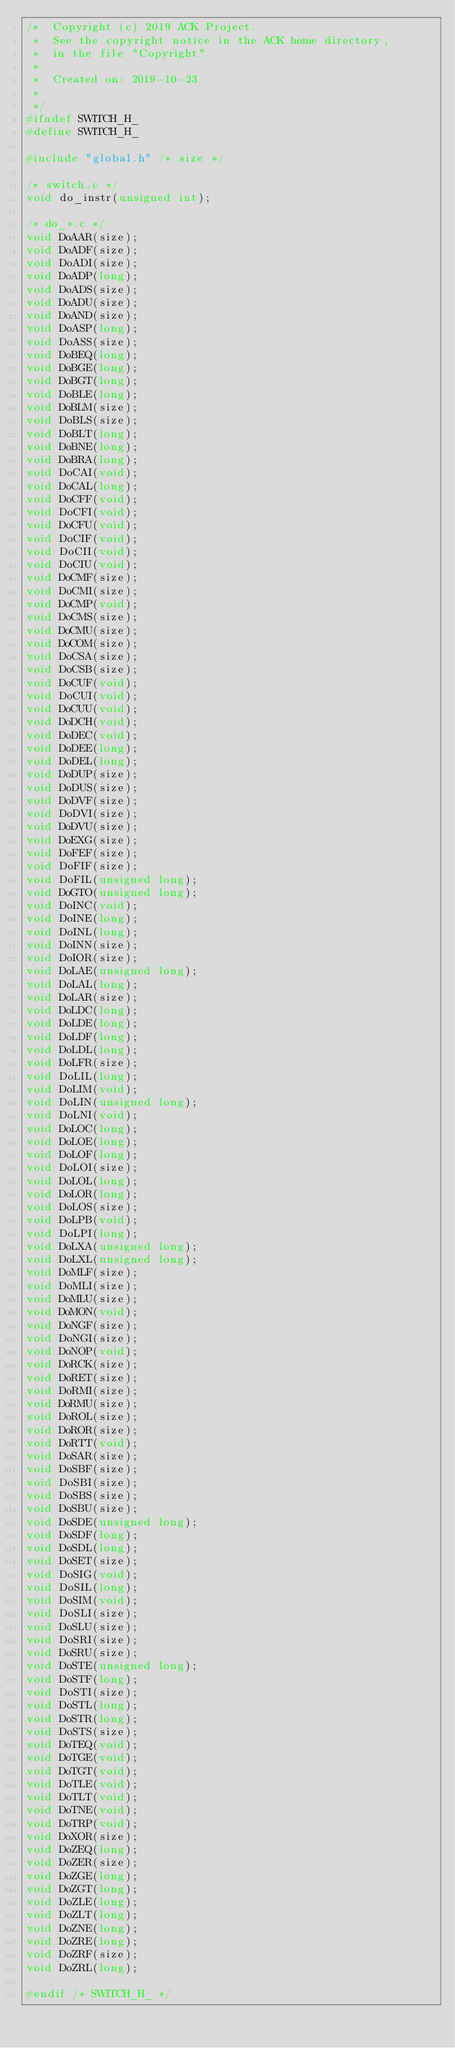Convert code to text. <code><loc_0><loc_0><loc_500><loc_500><_C_>/*  Copyright (c) 2019 ACK Project.
 *  See the copyright notice in the ACK home directory,
 *  in the file "Copyright".
 *
 *  Created on: 2019-10-23
 *
 */
#ifndef SWITCH_H_
#define SWITCH_H_

#include "global.h"	/* size */

/* switch.c */
void do_instr(unsigned int);

/* do_*.c */
void DoAAR(size);
void DoADF(size);
void DoADI(size);
void DoADP(long);
void DoADS(size);
void DoADU(size);
void DoAND(size);
void DoASP(long);
void DoASS(size);
void DoBEQ(long);
void DoBGE(long);
void DoBGT(long);
void DoBLE(long);
void DoBLM(size);
void DoBLS(size);
void DoBLT(long);
void DoBNE(long);
void DoBRA(long);
void DoCAI(void);
void DoCAL(long);
void DoCFF(void);
void DoCFI(void);
void DoCFU(void);
void DoCIF(void);
void DoCII(void);
void DoCIU(void);
void DoCMF(size);
void DoCMI(size);
void DoCMP(void);
void DoCMS(size);
void DoCMU(size);
void DoCOM(size);
void DoCSA(size);
void DoCSB(size);
void DoCUF(void);
void DoCUI(void);
void DoCUU(void);
void DoDCH(void);
void DoDEC(void);
void DoDEE(long);
void DoDEL(long);
void DoDUP(size);
void DoDUS(size);
void DoDVF(size);
void DoDVI(size);
void DoDVU(size);
void DoEXG(size);
void DoFEF(size);
void DoFIF(size);
void DoFIL(unsigned long);
void DoGTO(unsigned long);
void DoINC(void);
void DoINE(long);
void DoINL(long);
void DoINN(size);
void DoIOR(size);
void DoLAE(unsigned long);
void DoLAL(long);
void DoLAR(size);
void DoLDC(long);
void DoLDE(long);
void DoLDF(long);
void DoLDL(long);
void DoLFR(size);
void DoLIL(long);
void DoLIM(void);
void DoLIN(unsigned long);
void DoLNI(void);
void DoLOC(long);
void DoLOE(long);
void DoLOF(long);
void DoLOI(size);
void DoLOL(long);
void DoLOR(long);
void DoLOS(size);
void DoLPB(void);
void DoLPI(long);
void DoLXA(unsigned long);
void DoLXL(unsigned long);
void DoMLF(size);
void DoMLI(size);
void DoMLU(size);
void DoMON(void);
void DoNGF(size);
void DoNGI(size);
void DoNOP(void);
void DoRCK(size);
void DoRET(size);
void DoRMI(size);
void DoRMU(size);
void DoROL(size);
void DoROR(size);
void DoRTT(void);
void DoSAR(size);
void DoSBF(size);
void DoSBI(size);
void DoSBS(size);
void DoSBU(size);
void DoSDE(unsigned long);
void DoSDF(long);
void DoSDL(long);
void DoSET(size);
void DoSIG(void);
void DoSIL(long);
void DoSIM(void);
void DoSLI(size);
void DoSLU(size);
void DoSRI(size);
void DoSRU(size);
void DoSTE(unsigned long);
void DoSTF(long);
void DoSTI(size);
void DoSTL(long);
void DoSTR(long);
void DoSTS(size);
void DoTEQ(void);
void DoTGE(void);
void DoTGT(void);
void DoTLE(void);
void DoTLT(void);
void DoTNE(void);
void DoTRP(void);
void DoXOR(size);
void DoZEQ(long);
void DoZER(size);
void DoZGE(long);
void DoZGT(long);
void DoZLE(long);
void DoZLT(long);
void DoZNE(long);
void DoZRE(long);
void DoZRF(size);
void DoZRL(long);

#endif /* SWITCH_H_ */
</code> 